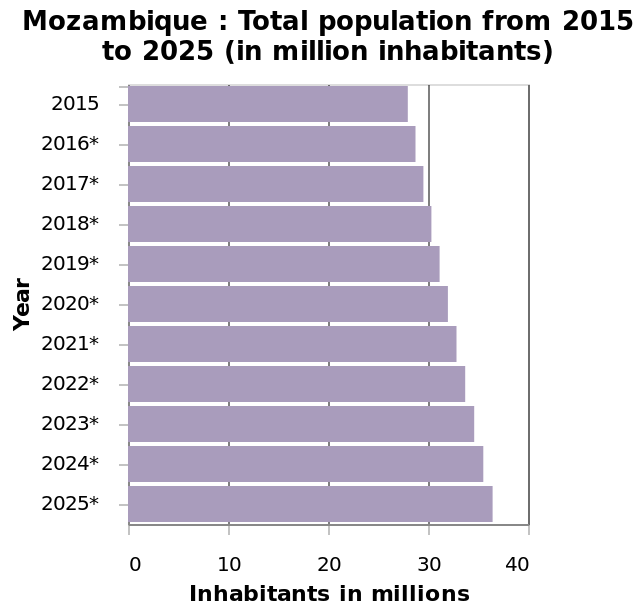<image>
Will there be any change in the population growth rate? No, the population is expected to continue growing at a steady rate. Is the population expected to decrease in the future? No, the population is predicted to continue increasing at a steady rate. What has been happening to the population year by year?  The population has continued to increase year by year. What is represented on the y-axis of the bar plot?  The y-axis of the bar plot represents the years from 2015 to 2025 on a categorical scale. 